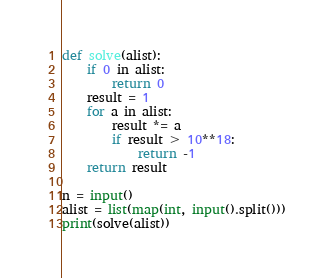Convert code to text. <code><loc_0><loc_0><loc_500><loc_500><_Python_>def solve(alist):
    if 0 in alist:
        return 0
    result = 1
    for a in alist:
        result *= a
        if result > 10**18:
            return -1
    return result

n = input()
alist = list(map(int, input().split()))
print(solve(alist))</code> 